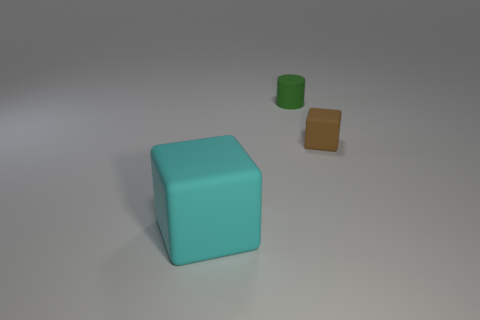What number of purple things are either big objects or tiny matte things?
Your answer should be compact. 0. Is the material of the large cube the same as the brown cube?
Your answer should be very brief. Yes. There is a tiny brown thing; what number of small cylinders are in front of it?
Offer a very short reply. 0. What material is the object that is to the left of the brown thing and to the right of the big rubber cube?
Give a very brief answer. Rubber. How many balls are either small green objects or tiny objects?
Provide a short and direct response. 0. There is another thing that is the same shape as the big object; what is its material?
Make the answer very short. Rubber. What size is the brown thing that is the same material as the cylinder?
Offer a very short reply. Small. Does the tiny rubber thing that is in front of the matte cylinder have the same shape as the object behind the brown matte block?
Your response must be concise. No. The tiny cylinder that is made of the same material as the small brown block is what color?
Your answer should be compact. Green. Do the thing on the left side of the small green matte cylinder and the matte object behind the small brown rubber block have the same size?
Give a very brief answer. No. 